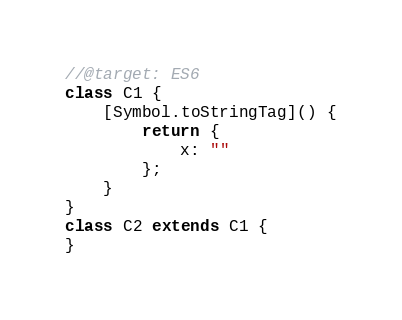<code> <loc_0><loc_0><loc_500><loc_500><_JavaScript_>//@target: ES6
class C1 {
    [Symbol.toStringTag]() {
        return {
            x: ""
        };
    }
}
class C2 extends C1 {
}
</code> 